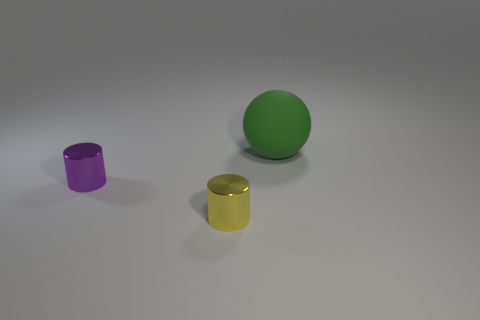Are there any other things that have the same material as the big green thing?
Your answer should be very brief. No. How big is the cylinder that is in front of the purple cylinder?
Keep it short and to the point. Small. Is there a small purple object made of the same material as the yellow object?
Your answer should be compact. Yes. What number of tiny purple things are the same shape as the tiny yellow shiny object?
Ensure brevity in your answer.  1. The green matte object to the right of the tiny shiny thing right of the small thing to the left of the tiny yellow metal cylinder is what shape?
Your answer should be compact. Sphere. The thing that is on the right side of the purple metal cylinder and behind the tiny yellow cylinder is made of what material?
Make the answer very short. Rubber. There is a object that is to the right of the yellow thing; is it the same size as the tiny purple metallic thing?
Make the answer very short. No. Are there any other things that have the same size as the matte thing?
Make the answer very short. No. Is the number of purple objects on the left side of the tiny purple shiny cylinder greater than the number of purple shiny objects that are behind the small yellow cylinder?
Provide a short and direct response. No. There is a cylinder on the left side of the cylinder to the right of the shiny cylinder behind the yellow thing; what color is it?
Your answer should be compact. Purple. 